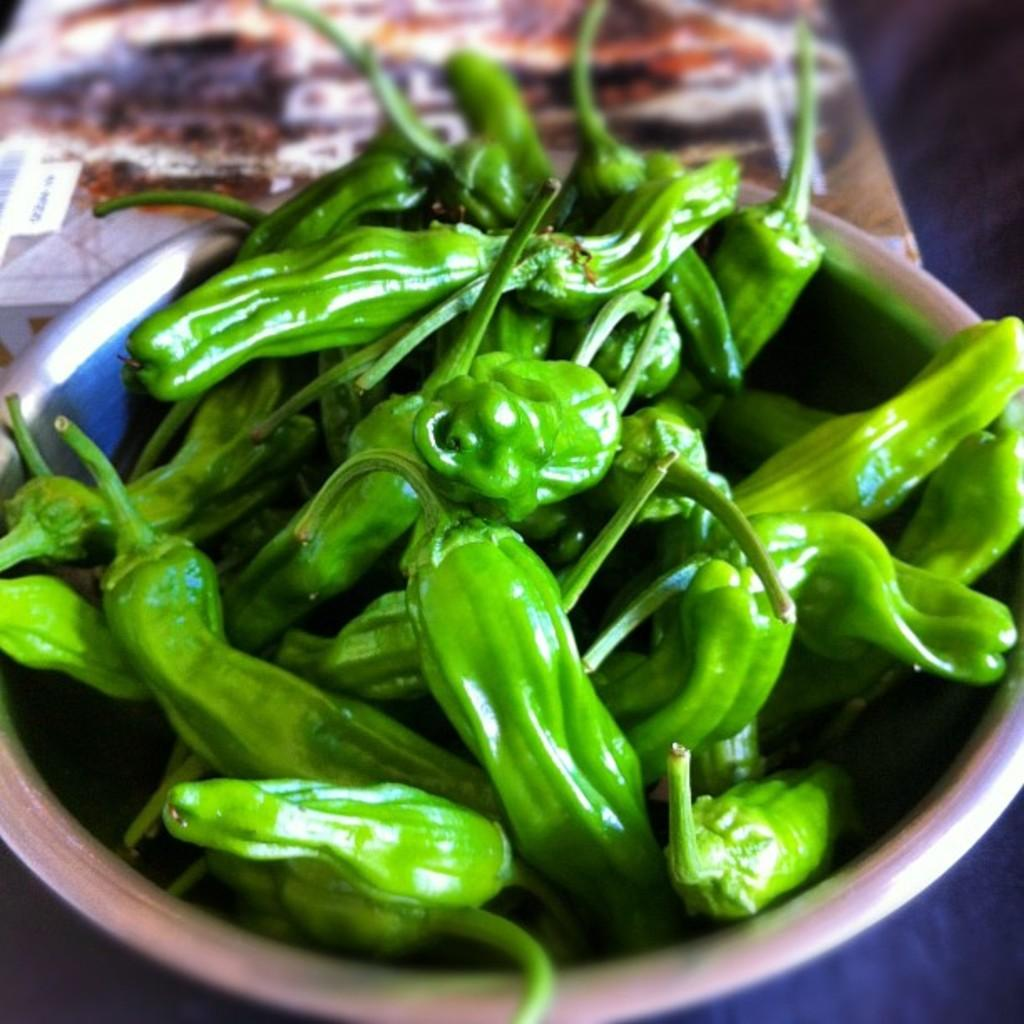What type of food is in the bowl in the image? There are green vegetables in a bowl in the image. Can you describe the background of the image? The background of the image is blurred. What type of plot can be seen in the image? There is no plot present in the image; it only contains a bowl of green vegetables and a blurred background. 